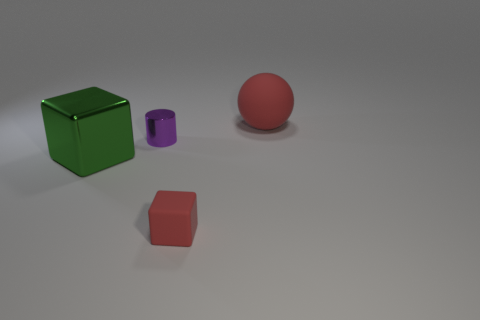Add 2 large red metal cubes. How many objects exist? 6 Subtract 0 yellow spheres. How many objects are left? 4 Subtract all green metal objects. Subtract all metallic objects. How many objects are left? 1 Add 2 big matte things. How many big matte things are left? 3 Add 2 tiny red things. How many tiny red things exist? 3 